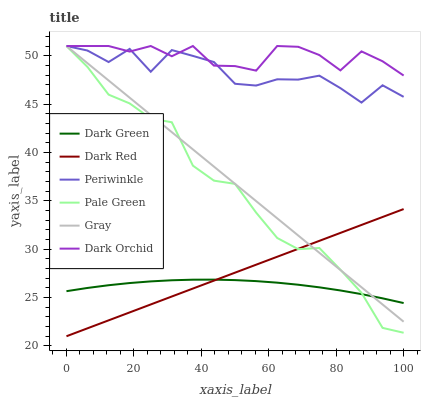Does Dark Green have the minimum area under the curve?
Answer yes or no. Yes. Does Dark Orchid have the maximum area under the curve?
Answer yes or no. Yes. Does Dark Red have the minimum area under the curve?
Answer yes or no. No. Does Dark Red have the maximum area under the curve?
Answer yes or no. No. Is Dark Red the smoothest?
Answer yes or no. Yes. Is Periwinkle the roughest?
Answer yes or no. Yes. Is Dark Orchid the smoothest?
Answer yes or no. No. Is Dark Orchid the roughest?
Answer yes or no. No. Does Dark Red have the lowest value?
Answer yes or no. Yes. Does Dark Orchid have the lowest value?
Answer yes or no. No. Does Periwinkle have the highest value?
Answer yes or no. Yes. Does Dark Red have the highest value?
Answer yes or no. No. Is Dark Red less than Dark Orchid?
Answer yes or no. Yes. Is Periwinkle greater than Dark Green?
Answer yes or no. Yes. Does Gray intersect Dark Orchid?
Answer yes or no. Yes. Is Gray less than Dark Orchid?
Answer yes or no. No. Is Gray greater than Dark Orchid?
Answer yes or no. No. Does Dark Red intersect Dark Orchid?
Answer yes or no. No. 